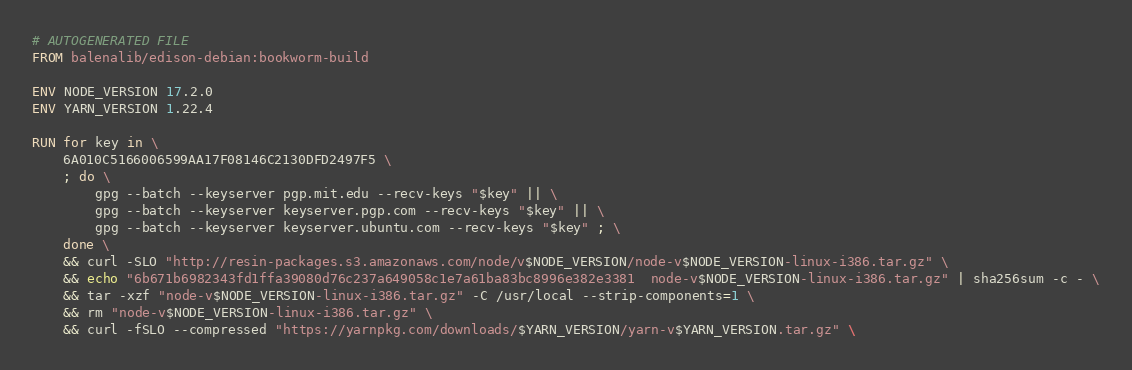Convert code to text. <code><loc_0><loc_0><loc_500><loc_500><_Dockerfile_># AUTOGENERATED FILE
FROM balenalib/edison-debian:bookworm-build

ENV NODE_VERSION 17.2.0
ENV YARN_VERSION 1.22.4

RUN for key in \
	6A010C5166006599AA17F08146C2130DFD2497F5 \
	; do \
		gpg --batch --keyserver pgp.mit.edu --recv-keys "$key" || \
		gpg --batch --keyserver keyserver.pgp.com --recv-keys "$key" || \
		gpg --batch --keyserver keyserver.ubuntu.com --recv-keys "$key" ; \
	done \
	&& curl -SLO "http://resin-packages.s3.amazonaws.com/node/v$NODE_VERSION/node-v$NODE_VERSION-linux-i386.tar.gz" \
	&& echo "6b671b6982343fd1ffa39080d76c237a649058c1e7a61ba83bc8996e382e3381  node-v$NODE_VERSION-linux-i386.tar.gz" | sha256sum -c - \
	&& tar -xzf "node-v$NODE_VERSION-linux-i386.tar.gz" -C /usr/local --strip-components=1 \
	&& rm "node-v$NODE_VERSION-linux-i386.tar.gz" \
	&& curl -fSLO --compressed "https://yarnpkg.com/downloads/$YARN_VERSION/yarn-v$YARN_VERSION.tar.gz" \</code> 